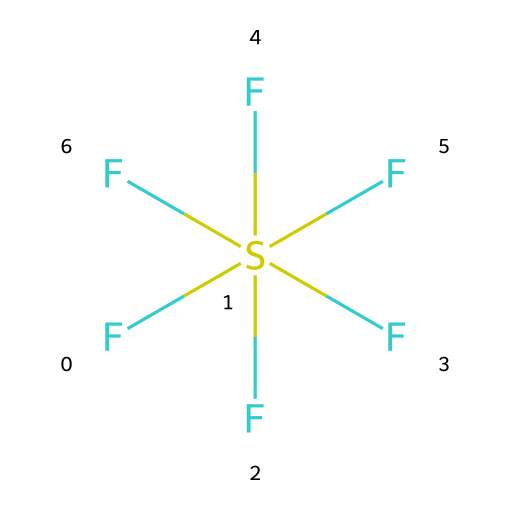What is the name of the chemical represented by this structure? The SMILES representation corresponds to a chemical with the formula SF6, which is known as sulfur hexafluoride.
Answer: sulfur hexafluoride How many fluorine atoms are in the molecule? The structure shows six fluorine atoms attached to a single sulfur atom, indicated by the six 'F' in the SMILES string.
Answer: six What type of hybridization does the sulfur atom exhibit? In SF6, the sulfur atom is surrounded by six fluorine atoms, which involves the use of d-orbitals for bonding, indicating sp3d2 hybridization.
Answer: sp3d2 Is sulfur hexafluoride a polar or nonpolar compound? The arrangement of the six identical fluorine atoms around the sulfur atom leads to a symmetrical molecule, making it nonpolar.
Answer: nonpolar What is the oxidation state of sulfur in sulfur hexafluoride? The oxidation state is determined by the number of bonds to more electronegative atoms; in this case, sulfur has an oxidation state of +6 due to six fluorine atoms.
Answer: +6 Does sulfur hexafluoride exhibit hypervalency? Yes, sulfur hexafluoride is an example of hypervalent compounds because the sulfur atom has more than four pairs of electrons surrounding it, owing to the six fluorine bonds.
Answer: yes 